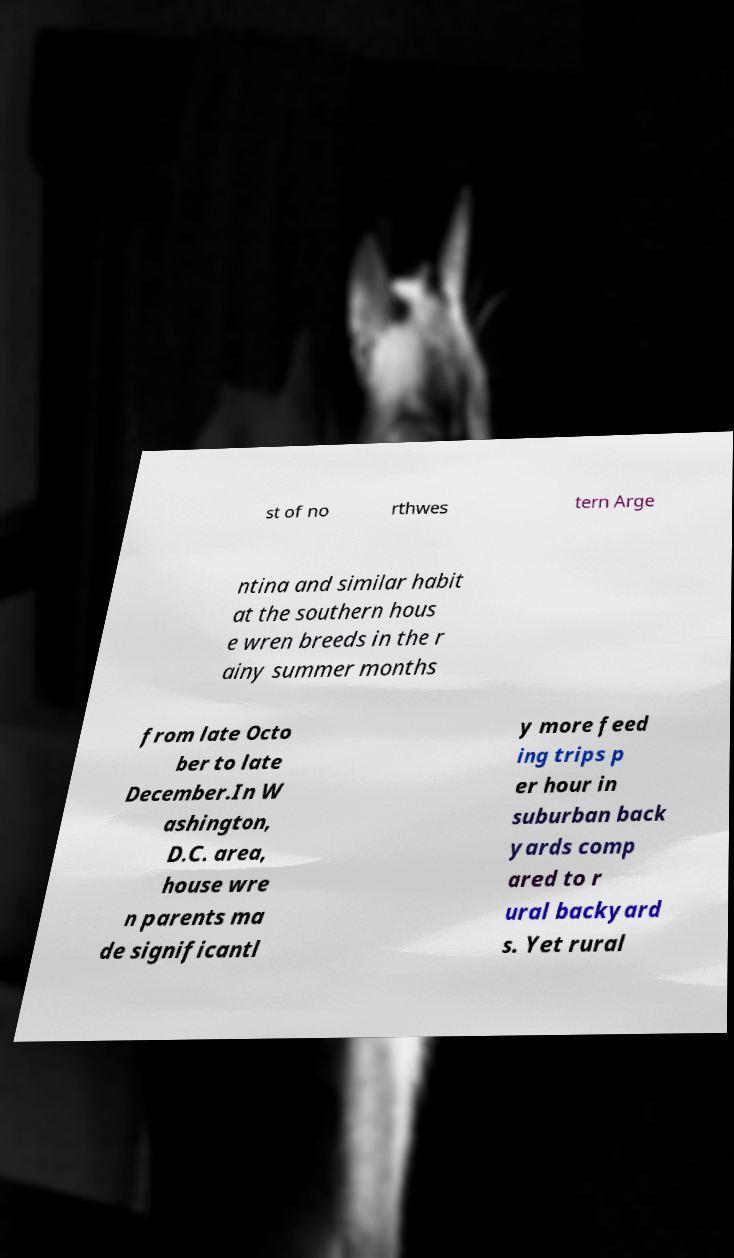Can you accurately transcribe the text from the provided image for me? st of no rthwes tern Arge ntina and similar habit at the southern hous e wren breeds in the r ainy summer months from late Octo ber to late December.In W ashington, D.C. area, house wre n parents ma de significantl y more feed ing trips p er hour in suburban back yards comp ared to r ural backyard s. Yet rural 